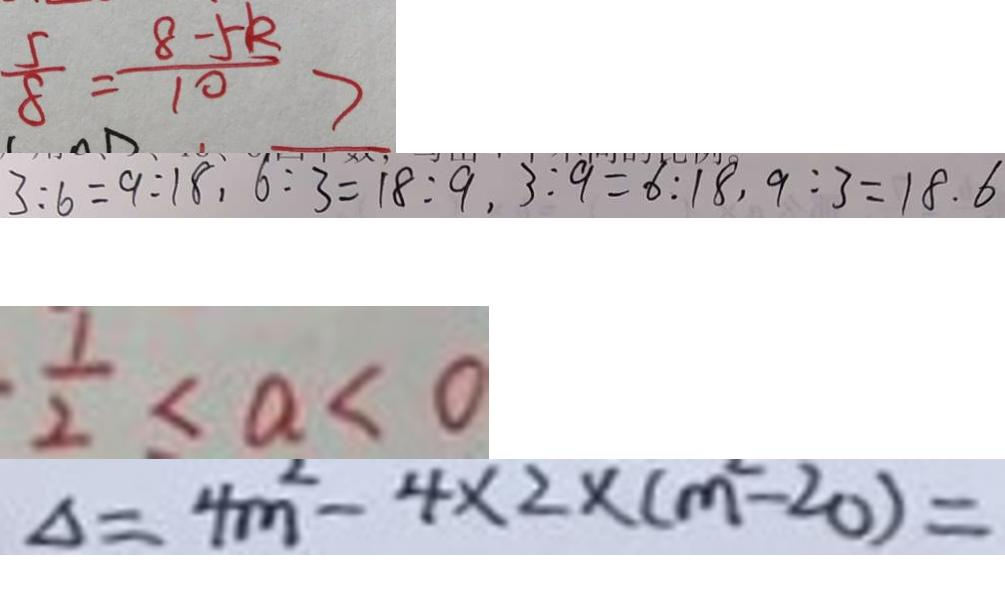<formula> <loc_0><loc_0><loc_500><loc_500>\frac { 5 } { 8 } = \frac { 8 - 5 k } { 1 0 } > 
 3 : 6 = 9 : 1 8 . 6 : 3 = 1 8 : 9 . 3 : 9 = 6 : 1 8 . 9 : 3 = 1 8 . 6 
 \frac { 1 } { 2 } < a < 0 
 \Delta = 4 m ^ { 2 } - 4 \times 2 \times ( m ^ { 2 } - 2 0 ) =</formula> 